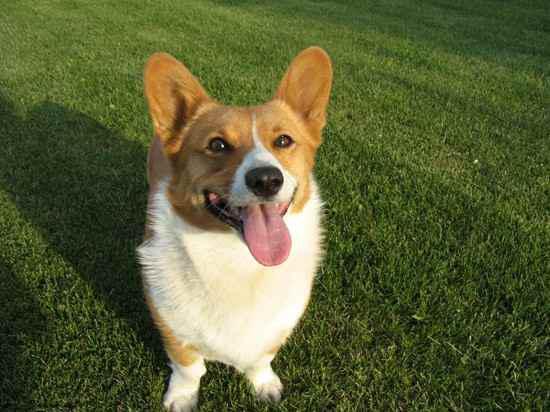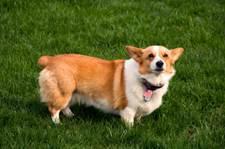The first image is the image on the left, the second image is the image on the right. Assess this claim about the two images: "The dog in the left image has its tongue out.". Correct or not? Answer yes or no. Yes. The first image is the image on the left, the second image is the image on the right. Examine the images to the left and right. Is the description "Each image contains one orange-and-white corgi dog, each of the depicted dogs has its face turned forward." accurate? Answer yes or no. Yes. 